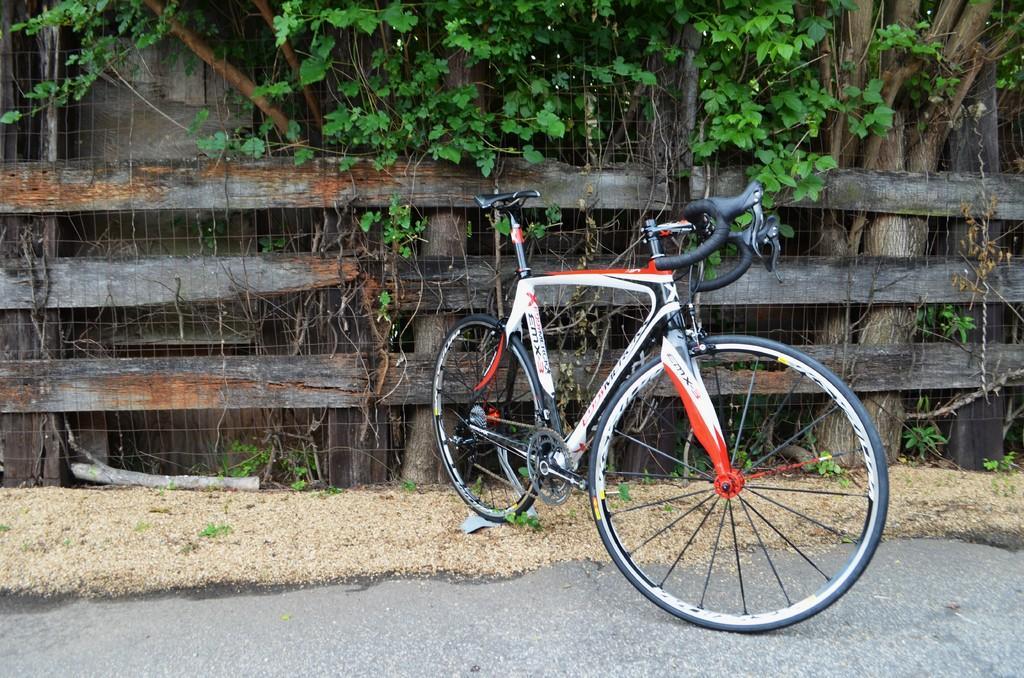Describe this image in one or two sentences. There is a bicycle parked on the road near a wooden fencing. Outside this fencing, there are trees and there is a wall. 